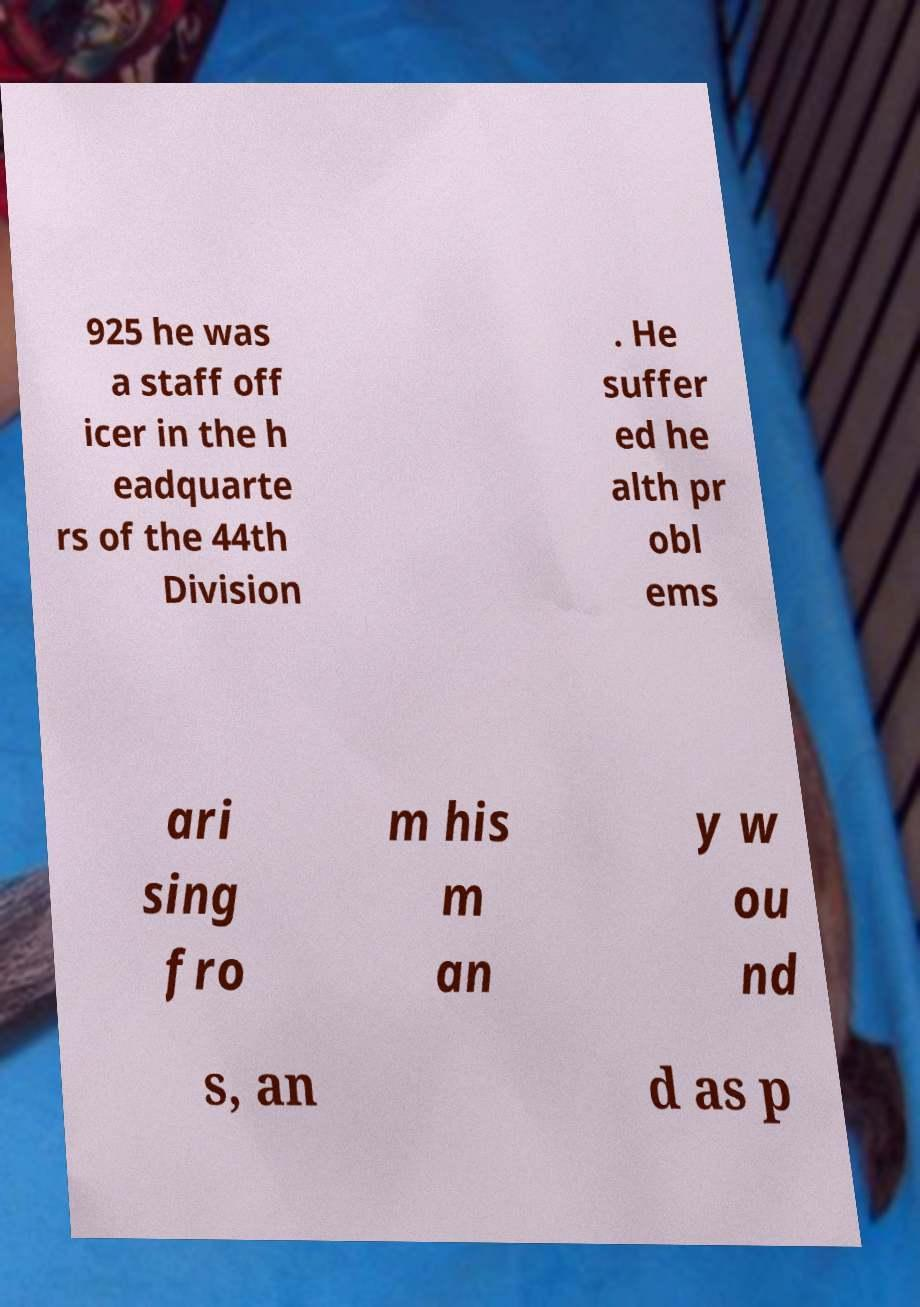I need the written content from this picture converted into text. Can you do that? 925 he was a staff off icer in the h eadquarte rs of the 44th Division . He suffer ed he alth pr obl ems ari sing fro m his m an y w ou nd s, an d as p 